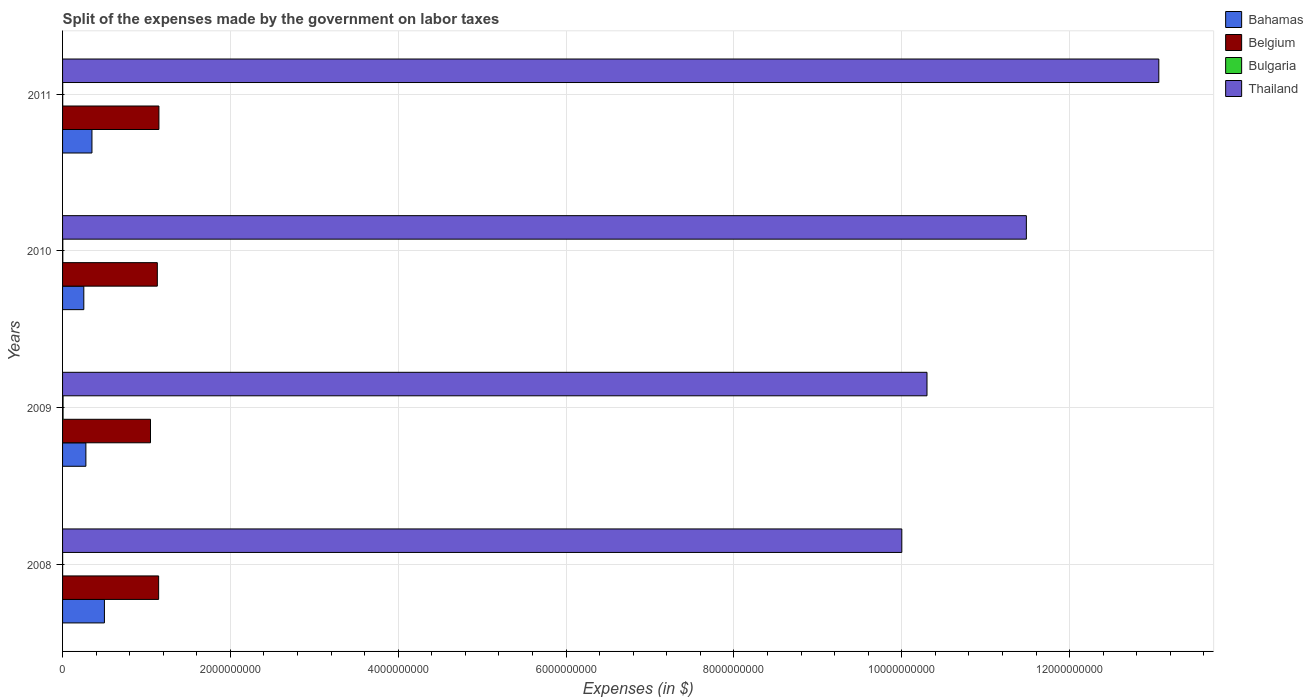How many groups of bars are there?
Your answer should be very brief. 4. Are the number of bars per tick equal to the number of legend labels?
Provide a succinct answer. Yes. What is the label of the 1st group of bars from the top?
Your answer should be very brief. 2011. What is the expenses made by the government on labor taxes in Bahamas in 2011?
Make the answer very short. 3.50e+08. Across all years, what is the maximum expenses made by the government on labor taxes in Bahamas?
Your answer should be very brief. 4.99e+08. Across all years, what is the minimum expenses made by the government on labor taxes in Bahamas?
Make the answer very short. 2.53e+08. In which year was the expenses made by the government on labor taxes in Bahamas minimum?
Offer a terse response. 2010. What is the total expenses made by the government on labor taxes in Bulgaria in the graph?
Offer a very short reply. 1.12e+07. What is the difference between the expenses made by the government on labor taxes in Bahamas in 2009 and that in 2011?
Offer a very short reply. -7.22e+07. What is the difference between the expenses made by the government on labor taxes in Belgium in 2010 and the expenses made by the government on labor taxes in Thailand in 2009?
Offer a very short reply. -9.17e+09. What is the average expenses made by the government on labor taxes in Belgium per year?
Offer a terse response. 1.12e+09. In the year 2011, what is the difference between the expenses made by the government on labor taxes in Belgium and expenses made by the government on labor taxes in Bahamas?
Your answer should be compact. 7.98e+08. In how many years, is the expenses made by the government on labor taxes in Belgium greater than 5600000000 $?
Make the answer very short. 0. What is the ratio of the expenses made by the government on labor taxes in Thailand in 2009 to that in 2010?
Make the answer very short. 0.9. Is the difference between the expenses made by the government on labor taxes in Belgium in 2010 and 2011 greater than the difference between the expenses made by the government on labor taxes in Bahamas in 2010 and 2011?
Your response must be concise. Yes. What is the difference between the highest and the second highest expenses made by the government on labor taxes in Bahamas?
Your response must be concise. 1.49e+08. What is the difference between the highest and the lowest expenses made by the government on labor taxes in Belgium?
Your response must be concise. 1.00e+08. What does the 4th bar from the bottom in 2009 represents?
Your answer should be compact. Thailand. What is the difference between two consecutive major ticks on the X-axis?
Give a very brief answer. 2.00e+09. Are the values on the major ticks of X-axis written in scientific E-notation?
Keep it short and to the point. No. Does the graph contain any zero values?
Your answer should be very brief. No. Where does the legend appear in the graph?
Offer a very short reply. Top right. How many legend labels are there?
Keep it short and to the point. 4. How are the legend labels stacked?
Offer a very short reply. Vertical. What is the title of the graph?
Offer a very short reply. Split of the expenses made by the government on labor taxes. Does "Europe(developing only)" appear as one of the legend labels in the graph?
Ensure brevity in your answer.  No. What is the label or title of the X-axis?
Your response must be concise. Expenses (in $). What is the label or title of the Y-axis?
Offer a terse response. Years. What is the Expenses (in $) of Bahamas in 2008?
Offer a terse response. 4.99e+08. What is the Expenses (in $) of Belgium in 2008?
Make the answer very short. 1.14e+09. What is the Expenses (in $) in Bulgaria in 2008?
Make the answer very short. 6.49e+05. What is the Expenses (in $) of Thailand in 2008?
Your answer should be very brief. 1.00e+1. What is the Expenses (in $) in Bahamas in 2009?
Ensure brevity in your answer.  2.78e+08. What is the Expenses (in $) of Belgium in 2009?
Provide a short and direct response. 1.05e+09. What is the Expenses (in $) in Bulgaria in 2009?
Provide a succinct answer. 5.89e+06. What is the Expenses (in $) in Thailand in 2009?
Offer a terse response. 1.03e+1. What is the Expenses (in $) in Bahamas in 2010?
Provide a succinct answer. 2.53e+08. What is the Expenses (in $) of Belgium in 2010?
Give a very brief answer. 1.13e+09. What is the Expenses (in $) of Bulgaria in 2010?
Keep it short and to the point. 2.94e+06. What is the Expenses (in $) in Thailand in 2010?
Keep it short and to the point. 1.15e+1. What is the Expenses (in $) in Bahamas in 2011?
Give a very brief answer. 3.50e+08. What is the Expenses (in $) of Belgium in 2011?
Your answer should be compact. 1.15e+09. What is the Expenses (in $) of Bulgaria in 2011?
Give a very brief answer. 1.70e+06. What is the Expenses (in $) in Thailand in 2011?
Make the answer very short. 1.31e+1. Across all years, what is the maximum Expenses (in $) of Bahamas?
Your answer should be compact. 4.99e+08. Across all years, what is the maximum Expenses (in $) in Belgium?
Offer a terse response. 1.15e+09. Across all years, what is the maximum Expenses (in $) of Bulgaria?
Give a very brief answer. 5.89e+06. Across all years, what is the maximum Expenses (in $) of Thailand?
Keep it short and to the point. 1.31e+1. Across all years, what is the minimum Expenses (in $) of Bahamas?
Provide a succinct answer. 2.53e+08. Across all years, what is the minimum Expenses (in $) of Belgium?
Provide a succinct answer. 1.05e+09. Across all years, what is the minimum Expenses (in $) of Bulgaria?
Your answer should be compact. 6.49e+05. What is the total Expenses (in $) in Bahamas in the graph?
Make the answer very short. 1.38e+09. What is the total Expenses (in $) in Belgium in the graph?
Offer a terse response. 4.47e+09. What is the total Expenses (in $) of Bulgaria in the graph?
Make the answer very short. 1.12e+07. What is the total Expenses (in $) of Thailand in the graph?
Keep it short and to the point. 4.48e+1. What is the difference between the Expenses (in $) of Bahamas in 2008 and that in 2009?
Your response must be concise. 2.21e+08. What is the difference between the Expenses (in $) of Belgium in 2008 and that in 2009?
Offer a terse response. 9.70e+07. What is the difference between the Expenses (in $) of Bulgaria in 2008 and that in 2009?
Ensure brevity in your answer.  -5.24e+06. What is the difference between the Expenses (in $) in Thailand in 2008 and that in 2009?
Give a very brief answer. -3.00e+08. What is the difference between the Expenses (in $) of Bahamas in 2008 and that in 2010?
Give a very brief answer. 2.46e+08. What is the difference between the Expenses (in $) of Belgium in 2008 and that in 2010?
Ensure brevity in your answer.  1.56e+07. What is the difference between the Expenses (in $) in Bulgaria in 2008 and that in 2010?
Provide a succinct answer. -2.29e+06. What is the difference between the Expenses (in $) of Thailand in 2008 and that in 2010?
Offer a very short reply. -1.48e+09. What is the difference between the Expenses (in $) of Bahamas in 2008 and that in 2011?
Your response must be concise. 1.49e+08. What is the difference between the Expenses (in $) of Belgium in 2008 and that in 2011?
Provide a succinct answer. -3.50e+06. What is the difference between the Expenses (in $) of Bulgaria in 2008 and that in 2011?
Your answer should be compact. -1.06e+06. What is the difference between the Expenses (in $) in Thailand in 2008 and that in 2011?
Your response must be concise. -3.06e+09. What is the difference between the Expenses (in $) in Bahamas in 2009 and that in 2010?
Keep it short and to the point. 2.47e+07. What is the difference between the Expenses (in $) of Belgium in 2009 and that in 2010?
Give a very brief answer. -8.14e+07. What is the difference between the Expenses (in $) of Bulgaria in 2009 and that in 2010?
Make the answer very short. 2.95e+06. What is the difference between the Expenses (in $) of Thailand in 2009 and that in 2010?
Offer a very short reply. -1.18e+09. What is the difference between the Expenses (in $) of Bahamas in 2009 and that in 2011?
Provide a short and direct response. -7.22e+07. What is the difference between the Expenses (in $) in Belgium in 2009 and that in 2011?
Your answer should be very brief. -1.00e+08. What is the difference between the Expenses (in $) of Bulgaria in 2009 and that in 2011?
Your answer should be compact. 4.18e+06. What is the difference between the Expenses (in $) in Thailand in 2009 and that in 2011?
Your answer should be compact. -2.76e+09. What is the difference between the Expenses (in $) in Bahamas in 2010 and that in 2011?
Give a very brief answer. -9.70e+07. What is the difference between the Expenses (in $) of Belgium in 2010 and that in 2011?
Your answer should be compact. -1.91e+07. What is the difference between the Expenses (in $) in Bulgaria in 2010 and that in 2011?
Your response must be concise. 1.23e+06. What is the difference between the Expenses (in $) in Thailand in 2010 and that in 2011?
Offer a very short reply. -1.58e+09. What is the difference between the Expenses (in $) of Bahamas in 2008 and the Expenses (in $) of Belgium in 2009?
Your response must be concise. -5.49e+08. What is the difference between the Expenses (in $) of Bahamas in 2008 and the Expenses (in $) of Bulgaria in 2009?
Keep it short and to the point. 4.93e+08. What is the difference between the Expenses (in $) in Bahamas in 2008 and the Expenses (in $) in Thailand in 2009?
Ensure brevity in your answer.  -9.80e+09. What is the difference between the Expenses (in $) in Belgium in 2008 and the Expenses (in $) in Bulgaria in 2009?
Offer a terse response. 1.14e+09. What is the difference between the Expenses (in $) in Belgium in 2008 and the Expenses (in $) in Thailand in 2009?
Your answer should be very brief. -9.16e+09. What is the difference between the Expenses (in $) in Bulgaria in 2008 and the Expenses (in $) in Thailand in 2009?
Give a very brief answer. -1.03e+1. What is the difference between the Expenses (in $) of Bahamas in 2008 and the Expenses (in $) of Belgium in 2010?
Offer a terse response. -6.30e+08. What is the difference between the Expenses (in $) in Bahamas in 2008 and the Expenses (in $) in Bulgaria in 2010?
Your answer should be very brief. 4.96e+08. What is the difference between the Expenses (in $) of Bahamas in 2008 and the Expenses (in $) of Thailand in 2010?
Provide a succinct answer. -1.10e+1. What is the difference between the Expenses (in $) of Belgium in 2008 and the Expenses (in $) of Bulgaria in 2010?
Your response must be concise. 1.14e+09. What is the difference between the Expenses (in $) in Belgium in 2008 and the Expenses (in $) in Thailand in 2010?
Keep it short and to the point. -1.03e+1. What is the difference between the Expenses (in $) in Bulgaria in 2008 and the Expenses (in $) in Thailand in 2010?
Offer a terse response. -1.15e+1. What is the difference between the Expenses (in $) in Bahamas in 2008 and the Expenses (in $) in Belgium in 2011?
Offer a very short reply. -6.50e+08. What is the difference between the Expenses (in $) in Bahamas in 2008 and the Expenses (in $) in Bulgaria in 2011?
Offer a very short reply. 4.97e+08. What is the difference between the Expenses (in $) in Bahamas in 2008 and the Expenses (in $) in Thailand in 2011?
Your answer should be very brief. -1.26e+1. What is the difference between the Expenses (in $) in Belgium in 2008 and the Expenses (in $) in Bulgaria in 2011?
Make the answer very short. 1.14e+09. What is the difference between the Expenses (in $) in Belgium in 2008 and the Expenses (in $) in Thailand in 2011?
Your answer should be very brief. -1.19e+1. What is the difference between the Expenses (in $) of Bulgaria in 2008 and the Expenses (in $) of Thailand in 2011?
Give a very brief answer. -1.31e+1. What is the difference between the Expenses (in $) in Bahamas in 2009 and the Expenses (in $) in Belgium in 2010?
Offer a very short reply. -8.51e+08. What is the difference between the Expenses (in $) of Bahamas in 2009 and the Expenses (in $) of Bulgaria in 2010?
Offer a very short reply. 2.75e+08. What is the difference between the Expenses (in $) in Bahamas in 2009 and the Expenses (in $) in Thailand in 2010?
Your answer should be compact. -1.12e+1. What is the difference between the Expenses (in $) of Belgium in 2009 and the Expenses (in $) of Bulgaria in 2010?
Keep it short and to the point. 1.04e+09. What is the difference between the Expenses (in $) in Belgium in 2009 and the Expenses (in $) in Thailand in 2010?
Your answer should be compact. -1.04e+1. What is the difference between the Expenses (in $) in Bulgaria in 2009 and the Expenses (in $) in Thailand in 2010?
Offer a terse response. -1.15e+1. What is the difference between the Expenses (in $) of Bahamas in 2009 and the Expenses (in $) of Belgium in 2011?
Your answer should be compact. -8.70e+08. What is the difference between the Expenses (in $) in Bahamas in 2009 and the Expenses (in $) in Bulgaria in 2011?
Ensure brevity in your answer.  2.76e+08. What is the difference between the Expenses (in $) in Bahamas in 2009 and the Expenses (in $) in Thailand in 2011?
Ensure brevity in your answer.  -1.28e+1. What is the difference between the Expenses (in $) of Belgium in 2009 and the Expenses (in $) of Bulgaria in 2011?
Offer a very short reply. 1.05e+09. What is the difference between the Expenses (in $) of Belgium in 2009 and the Expenses (in $) of Thailand in 2011?
Provide a succinct answer. -1.20e+1. What is the difference between the Expenses (in $) in Bulgaria in 2009 and the Expenses (in $) in Thailand in 2011?
Ensure brevity in your answer.  -1.31e+1. What is the difference between the Expenses (in $) of Bahamas in 2010 and the Expenses (in $) of Belgium in 2011?
Your response must be concise. -8.95e+08. What is the difference between the Expenses (in $) in Bahamas in 2010 and the Expenses (in $) in Bulgaria in 2011?
Provide a succinct answer. 2.51e+08. What is the difference between the Expenses (in $) in Bahamas in 2010 and the Expenses (in $) in Thailand in 2011?
Provide a short and direct response. -1.28e+1. What is the difference between the Expenses (in $) in Belgium in 2010 and the Expenses (in $) in Bulgaria in 2011?
Provide a succinct answer. 1.13e+09. What is the difference between the Expenses (in $) of Belgium in 2010 and the Expenses (in $) of Thailand in 2011?
Ensure brevity in your answer.  -1.19e+1. What is the difference between the Expenses (in $) in Bulgaria in 2010 and the Expenses (in $) in Thailand in 2011?
Your answer should be very brief. -1.31e+1. What is the average Expenses (in $) in Bahamas per year?
Ensure brevity in your answer.  3.45e+08. What is the average Expenses (in $) in Belgium per year?
Keep it short and to the point. 1.12e+09. What is the average Expenses (in $) of Bulgaria per year?
Your answer should be very brief. 2.79e+06. What is the average Expenses (in $) in Thailand per year?
Your answer should be very brief. 1.12e+1. In the year 2008, what is the difference between the Expenses (in $) in Bahamas and Expenses (in $) in Belgium?
Ensure brevity in your answer.  -6.46e+08. In the year 2008, what is the difference between the Expenses (in $) of Bahamas and Expenses (in $) of Bulgaria?
Provide a short and direct response. 4.98e+08. In the year 2008, what is the difference between the Expenses (in $) of Bahamas and Expenses (in $) of Thailand?
Offer a terse response. -9.50e+09. In the year 2008, what is the difference between the Expenses (in $) in Belgium and Expenses (in $) in Bulgaria?
Offer a very short reply. 1.14e+09. In the year 2008, what is the difference between the Expenses (in $) in Belgium and Expenses (in $) in Thailand?
Provide a succinct answer. -8.86e+09. In the year 2008, what is the difference between the Expenses (in $) in Bulgaria and Expenses (in $) in Thailand?
Your answer should be compact. -1.00e+1. In the year 2009, what is the difference between the Expenses (in $) in Bahamas and Expenses (in $) in Belgium?
Your response must be concise. -7.70e+08. In the year 2009, what is the difference between the Expenses (in $) of Bahamas and Expenses (in $) of Bulgaria?
Your answer should be compact. 2.72e+08. In the year 2009, what is the difference between the Expenses (in $) of Bahamas and Expenses (in $) of Thailand?
Your response must be concise. -1.00e+1. In the year 2009, what is the difference between the Expenses (in $) of Belgium and Expenses (in $) of Bulgaria?
Make the answer very short. 1.04e+09. In the year 2009, what is the difference between the Expenses (in $) of Belgium and Expenses (in $) of Thailand?
Make the answer very short. -9.25e+09. In the year 2009, what is the difference between the Expenses (in $) in Bulgaria and Expenses (in $) in Thailand?
Provide a short and direct response. -1.03e+1. In the year 2010, what is the difference between the Expenses (in $) in Bahamas and Expenses (in $) in Belgium?
Make the answer very short. -8.76e+08. In the year 2010, what is the difference between the Expenses (in $) of Bahamas and Expenses (in $) of Bulgaria?
Your response must be concise. 2.50e+08. In the year 2010, what is the difference between the Expenses (in $) in Bahamas and Expenses (in $) in Thailand?
Keep it short and to the point. -1.12e+1. In the year 2010, what is the difference between the Expenses (in $) in Belgium and Expenses (in $) in Bulgaria?
Your answer should be very brief. 1.13e+09. In the year 2010, what is the difference between the Expenses (in $) of Belgium and Expenses (in $) of Thailand?
Provide a short and direct response. -1.04e+1. In the year 2010, what is the difference between the Expenses (in $) of Bulgaria and Expenses (in $) of Thailand?
Keep it short and to the point. -1.15e+1. In the year 2011, what is the difference between the Expenses (in $) in Bahamas and Expenses (in $) in Belgium?
Offer a terse response. -7.98e+08. In the year 2011, what is the difference between the Expenses (in $) of Bahamas and Expenses (in $) of Bulgaria?
Provide a short and direct response. 3.48e+08. In the year 2011, what is the difference between the Expenses (in $) of Bahamas and Expenses (in $) of Thailand?
Your response must be concise. -1.27e+1. In the year 2011, what is the difference between the Expenses (in $) in Belgium and Expenses (in $) in Bulgaria?
Give a very brief answer. 1.15e+09. In the year 2011, what is the difference between the Expenses (in $) in Belgium and Expenses (in $) in Thailand?
Keep it short and to the point. -1.19e+1. In the year 2011, what is the difference between the Expenses (in $) of Bulgaria and Expenses (in $) of Thailand?
Make the answer very short. -1.31e+1. What is the ratio of the Expenses (in $) in Bahamas in 2008 to that in 2009?
Make the answer very short. 1.79. What is the ratio of the Expenses (in $) in Belgium in 2008 to that in 2009?
Your answer should be very brief. 1.09. What is the ratio of the Expenses (in $) of Bulgaria in 2008 to that in 2009?
Your response must be concise. 0.11. What is the ratio of the Expenses (in $) of Thailand in 2008 to that in 2009?
Offer a terse response. 0.97. What is the ratio of the Expenses (in $) in Bahamas in 2008 to that in 2010?
Provide a succinct answer. 1.97. What is the ratio of the Expenses (in $) in Belgium in 2008 to that in 2010?
Give a very brief answer. 1.01. What is the ratio of the Expenses (in $) in Bulgaria in 2008 to that in 2010?
Ensure brevity in your answer.  0.22. What is the ratio of the Expenses (in $) of Thailand in 2008 to that in 2010?
Offer a terse response. 0.87. What is the ratio of the Expenses (in $) in Bahamas in 2008 to that in 2011?
Give a very brief answer. 1.42. What is the ratio of the Expenses (in $) in Belgium in 2008 to that in 2011?
Your answer should be very brief. 1. What is the ratio of the Expenses (in $) of Bulgaria in 2008 to that in 2011?
Your response must be concise. 0.38. What is the ratio of the Expenses (in $) of Thailand in 2008 to that in 2011?
Your answer should be compact. 0.77. What is the ratio of the Expenses (in $) of Bahamas in 2009 to that in 2010?
Offer a terse response. 1.1. What is the ratio of the Expenses (in $) of Belgium in 2009 to that in 2010?
Offer a very short reply. 0.93. What is the ratio of the Expenses (in $) in Bulgaria in 2009 to that in 2010?
Provide a short and direct response. 2.01. What is the ratio of the Expenses (in $) in Thailand in 2009 to that in 2010?
Ensure brevity in your answer.  0.9. What is the ratio of the Expenses (in $) of Bahamas in 2009 to that in 2011?
Make the answer very short. 0.79. What is the ratio of the Expenses (in $) in Belgium in 2009 to that in 2011?
Ensure brevity in your answer.  0.91. What is the ratio of the Expenses (in $) of Bulgaria in 2009 to that in 2011?
Make the answer very short. 3.45. What is the ratio of the Expenses (in $) in Thailand in 2009 to that in 2011?
Ensure brevity in your answer.  0.79. What is the ratio of the Expenses (in $) in Bahamas in 2010 to that in 2011?
Provide a short and direct response. 0.72. What is the ratio of the Expenses (in $) in Belgium in 2010 to that in 2011?
Give a very brief answer. 0.98. What is the ratio of the Expenses (in $) of Bulgaria in 2010 to that in 2011?
Give a very brief answer. 1.72. What is the ratio of the Expenses (in $) of Thailand in 2010 to that in 2011?
Provide a short and direct response. 0.88. What is the difference between the highest and the second highest Expenses (in $) in Bahamas?
Your response must be concise. 1.49e+08. What is the difference between the highest and the second highest Expenses (in $) of Belgium?
Make the answer very short. 3.50e+06. What is the difference between the highest and the second highest Expenses (in $) in Bulgaria?
Offer a terse response. 2.95e+06. What is the difference between the highest and the second highest Expenses (in $) of Thailand?
Your answer should be very brief. 1.58e+09. What is the difference between the highest and the lowest Expenses (in $) of Bahamas?
Offer a terse response. 2.46e+08. What is the difference between the highest and the lowest Expenses (in $) of Belgium?
Offer a very short reply. 1.00e+08. What is the difference between the highest and the lowest Expenses (in $) in Bulgaria?
Your answer should be very brief. 5.24e+06. What is the difference between the highest and the lowest Expenses (in $) of Thailand?
Your answer should be compact. 3.06e+09. 